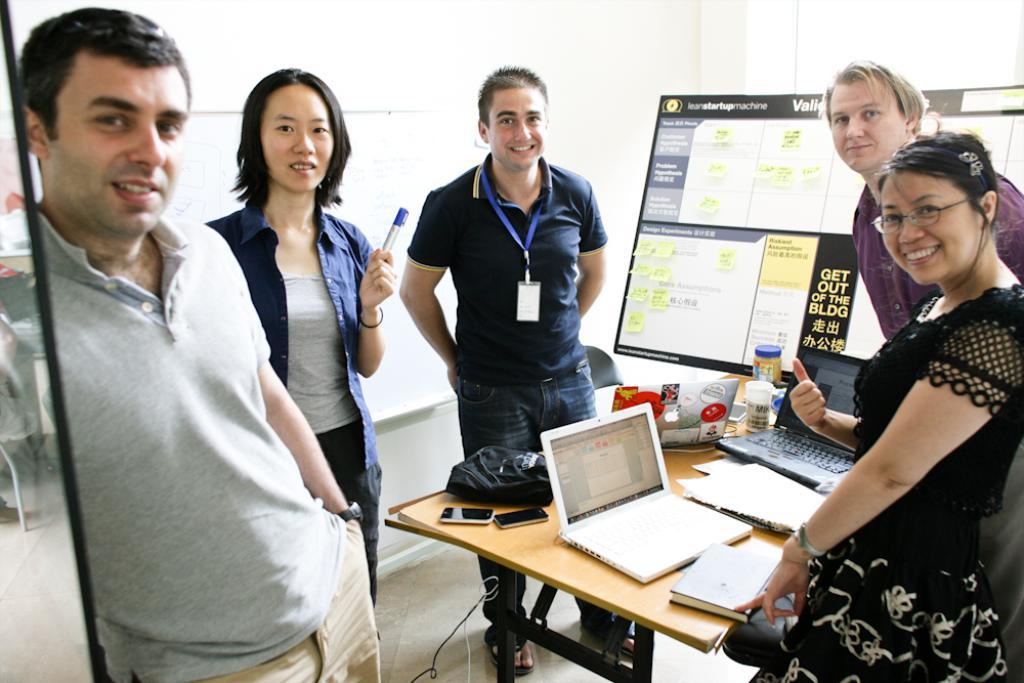How many people are present in the image? There are five persons in the image. What objects can be seen on the table in the image? There is a laptop, a mobile, a bag, and a bottle on the table. What type of nut is being used to make a payment in the image? There is no nut or payment being made in the image. Is there a notebook visible on the table in the image? No, there is no notebook present in the image. 